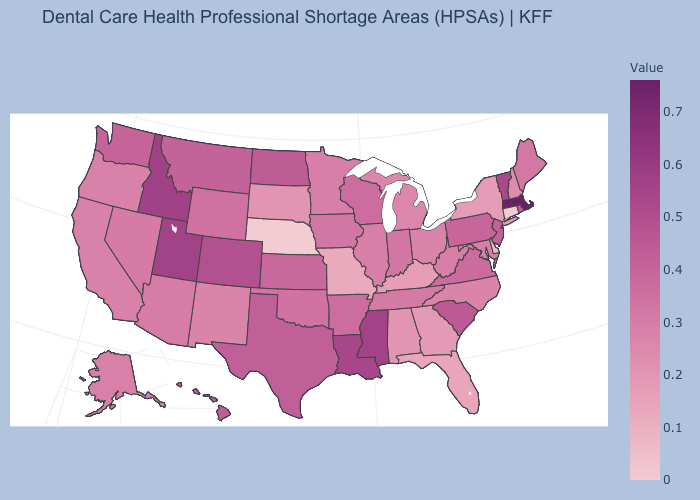Does Massachusetts have the highest value in the USA?
Quick response, please. Yes. Does Maryland have the highest value in the USA?
Write a very short answer. No. Does Virginia have the lowest value in the USA?
Write a very short answer. No. 